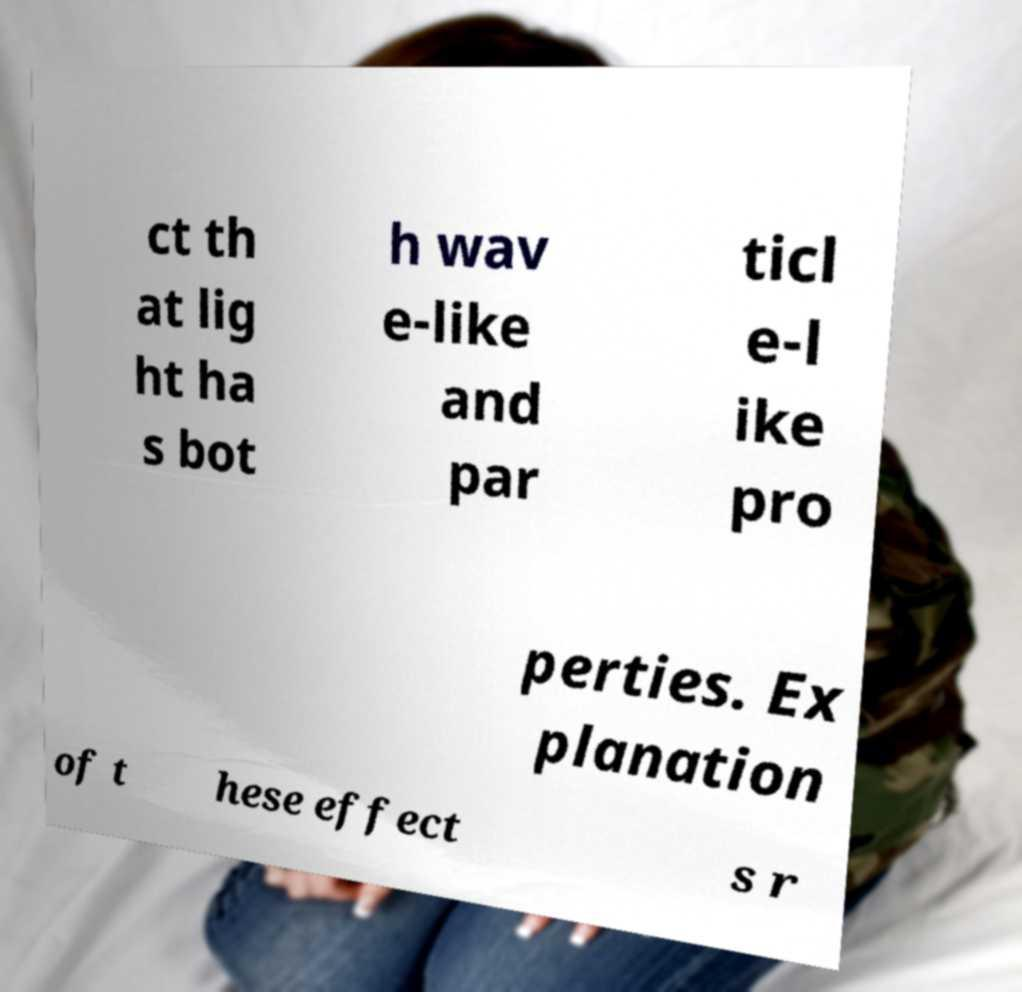I need the written content from this picture converted into text. Can you do that? ct th at lig ht ha s bot h wav e-like and par ticl e-l ike pro perties. Ex planation of t hese effect s r 